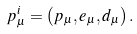Convert formula to latex. <formula><loc_0><loc_0><loc_500><loc_500>p _ { \mu } ^ { i } = \left ( p _ { \mu } , e _ { \mu } , d _ { \mu } \right ) .</formula> 